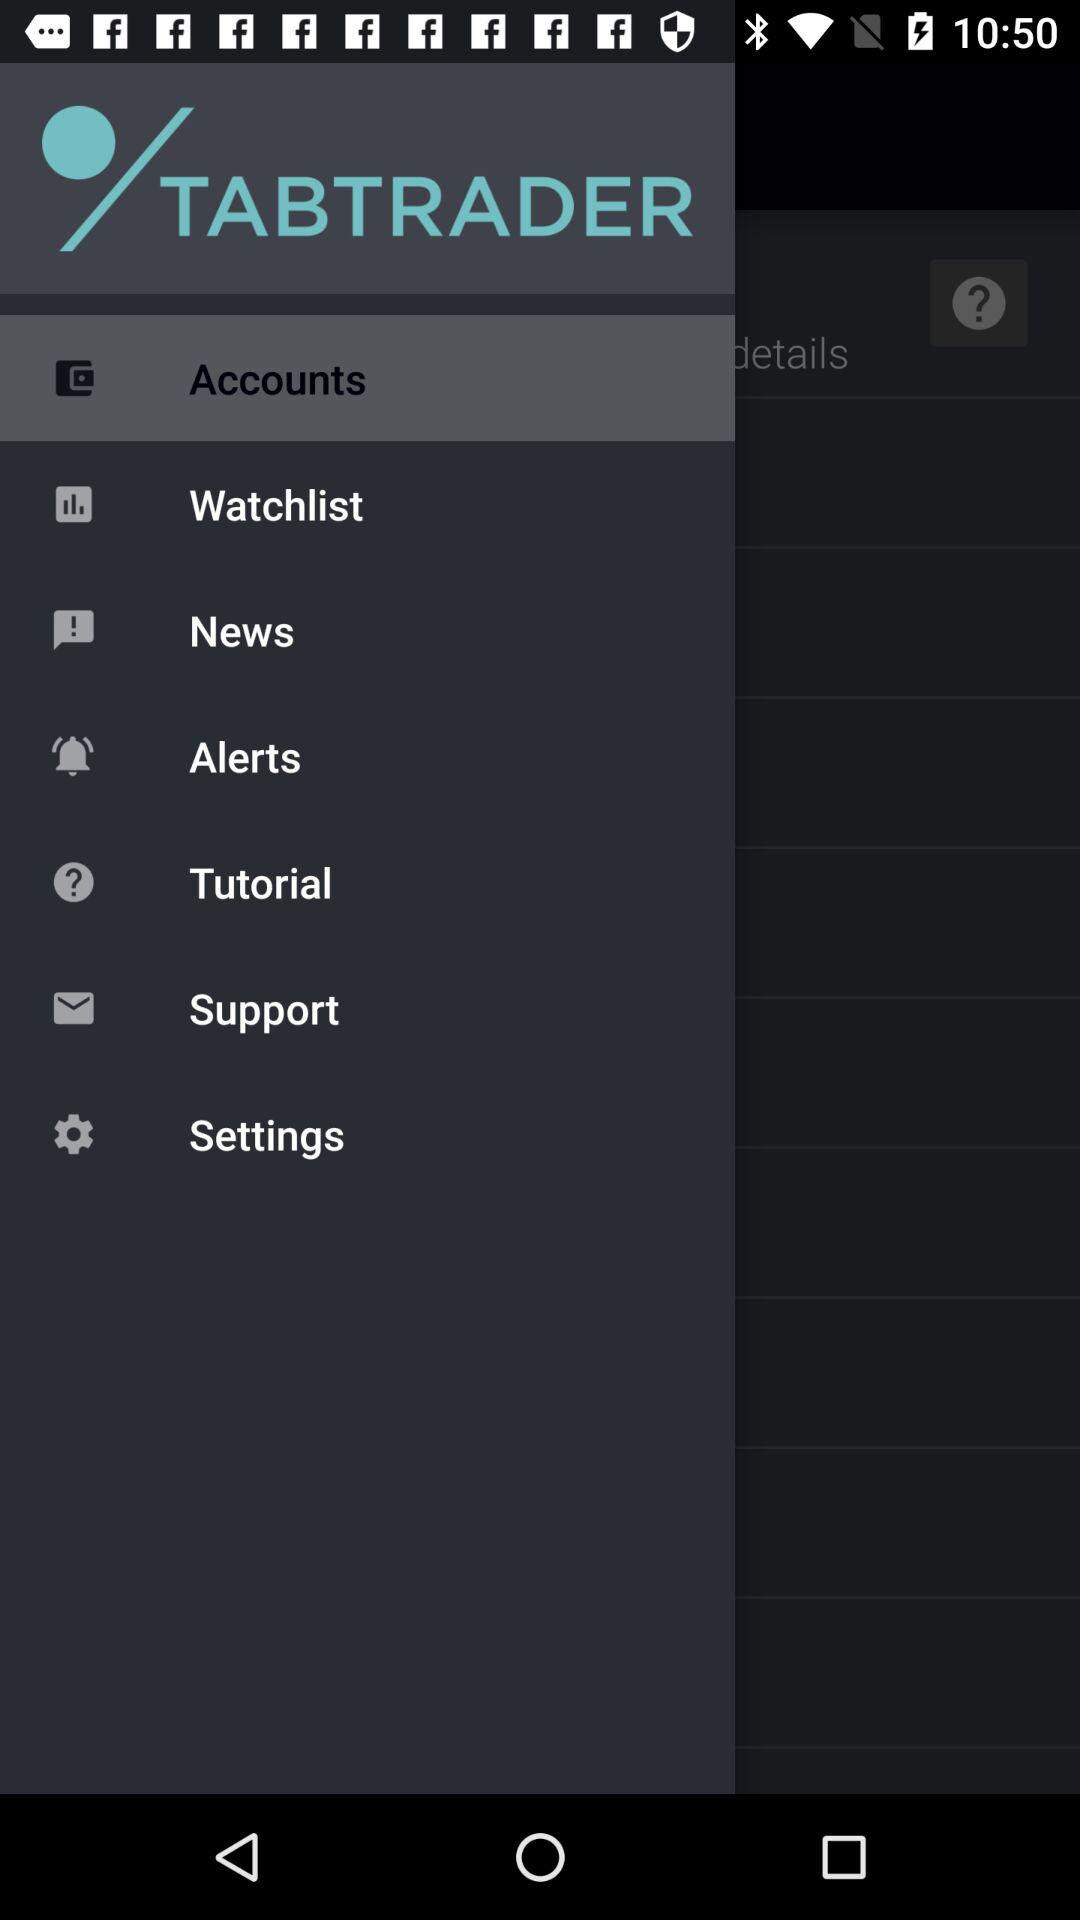When was "TABTRADER" copyrighted?
When the provided information is insufficient, respond with <no answer>. <no answer> 